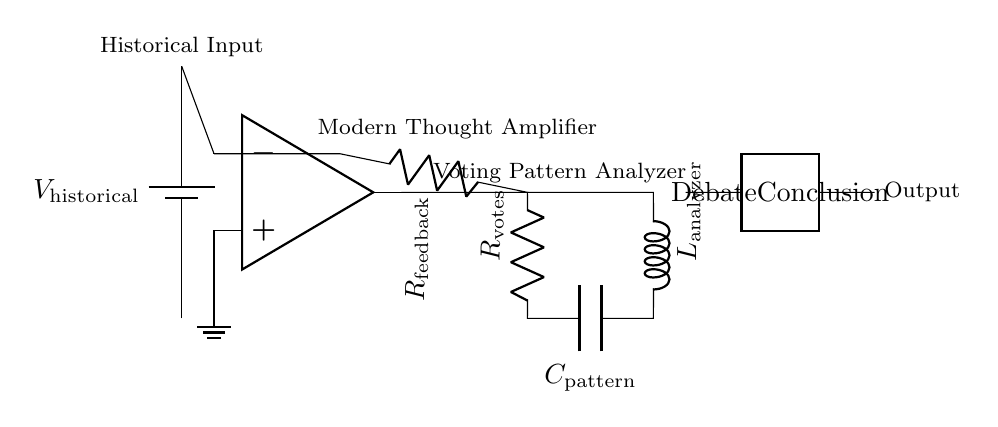What type of component is used for historical input? The component used for historical input is a battery, which provides the voltage source representing the thoughts of historical philosophers.
Answer: battery What does the feedback resistor do in this circuit? The feedback resistor creates a feedback loop for the operational amplifier, allowing for iterative analysis of the input signal, this feedback is important for stabilizing the output based on the input analysis.
Answer: feedback What is the role of the inductor in this circuit? The inductor, labeled as the pattern analyzer, is designed to analyze the voting patterns derived from the output of the operational amplifier, by responding to changes in current over time, thus playing a critical role in the dynamic observation of the voting patterns.
Answer: pattern analyzer How many main functional blocks are present in the circuit? The circuit contains four main functional blocks: historical input source, modern thought amplifier, voting pattern analyzer, and output representing debate conclusions.
Answer: four What is the output of this circuit labeled as? The output of the circuit is labeled as "Debate Conclusion," indicating that it summarizes the results of the analysis performed by the circuit components.
Answer: Debate Conclusion What do the components R and C represent in this circuit? The resistor R is referred to as the votes resistor, and the capacitor C is labeled as the pattern capacitor; they together filter and analyze the voting patterns over time by controlling the charge and discharge rates in the circuit.
Answer: votes and pattern 